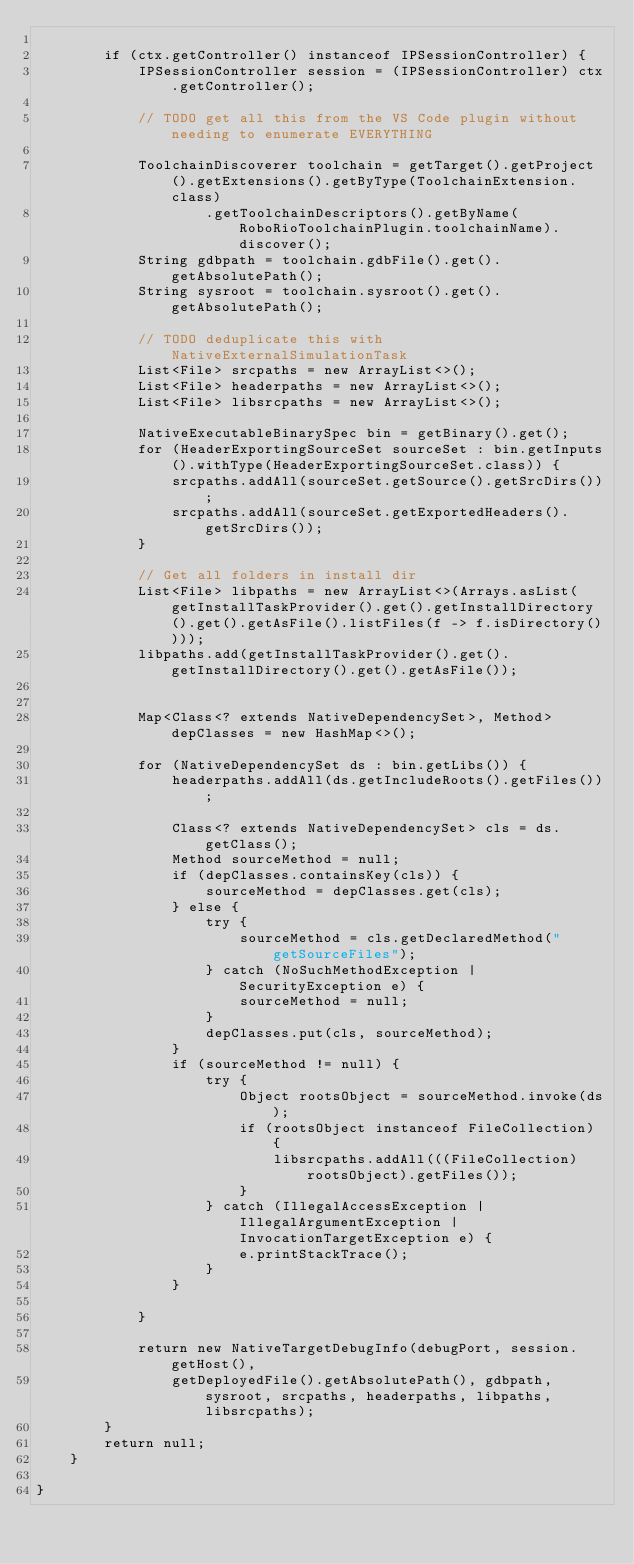<code> <loc_0><loc_0><loc_500><loc_500><_Java_>
        if (ctx.getController() instanceof IPSessionController) {
            IPSessionController session = (IPSessionController) ctx.getController();

            // TODO get all this from the VS Code plugin without needing to enumerate EVERYTHING

            ToolchainDiscoverer toolchain = getTarget().getProject().getExtensions().getByType(ToolchainExtension.class)
                    .getToolchainDescriptors().getByName(RoboRioToolchainPlugin.toolchainName).discover();
            String gdbpath = toolchain.gdbFile().get().getAbsolutePath();
            String sysroot = toolchain.sysroot().get().getAbsolutePath();

            // TODO deduplicate this with NativeExternalSimulationTask
            List<File> srcpaths = new ArrayList<>();
            List<File> headerpaths = new ArrayList<>();
            List<File> libsrcpaths = new ArrayList<>();

            NativeExecutableBinarySpec bin = getBinary().get();
            for (HeaderExportingSourceSet sourceSet : bin.getInputs().withType(HeaderExportingSourceSet.class)) {
                srcpaths.addAll(sourceSet.getSource().getSrcDirs());
                srcpaths.addAll(sourceSet.getExportedHeaders().getSrcDirs());
            }

            // Get all folders in install dir
            List<File> libpaths = new ArrayList<>(Arrays.asList(getInstallTaskProvider().get().getInstallDirectory().get().getAsFile().listFiles(f -> f.isDirectory())));
            libpaths.add(getInstallTaskProvider().get().getInstallDirectory().get().getAsFile());


            Map<Class<? extends NativeDependencySet>, Method> depClasses = new HashMap<>();

            for (NativeDependencySet ds : bin.getLibs()) {
                headerpaths.addAll(ds.getIncludeRoots().getFiles());

                Class<? extends NativeDependencySet> cls = ds.getClass();
                Method sourceMethod = null;
                if (depClasses.containsKey(cls)) {
                    sourceMethod = depClasses.get(cls);
                } else {
                    try {
                        sourceMethod = cls.getDeclaredMethod("getSourceFiles");
                    } catch (NoSuchMethodException | SecurityException e) {
                        sourceMethod = null;
                    }
                    depClasses.put(cls, sourceMethod);
                }
                if (sourceMethod != null) {
                    try {
                        Object rootsObject = sourceMethod.invoke(ds);
                        if (rootsObject instanceof FileCollection) {
                            libsrcpaths.addAll(((FileCollection) rootsObject).getFiles());
                        }
                    } catch (IllegalAccessException | IllegalArgumentException | InvocationTargetException e) {
                        e.printStackTrace();
                    }
                }

            }

            return new NativeTargetDebugInfo(debugPort, session.getHost(),
                getDeployedFile().getAbsolutePath(), gdbpath, sysroot, srcpaths, headerpaths, libpaths, libsrcpaths);
        }
        return null;
    }

}
</code> 